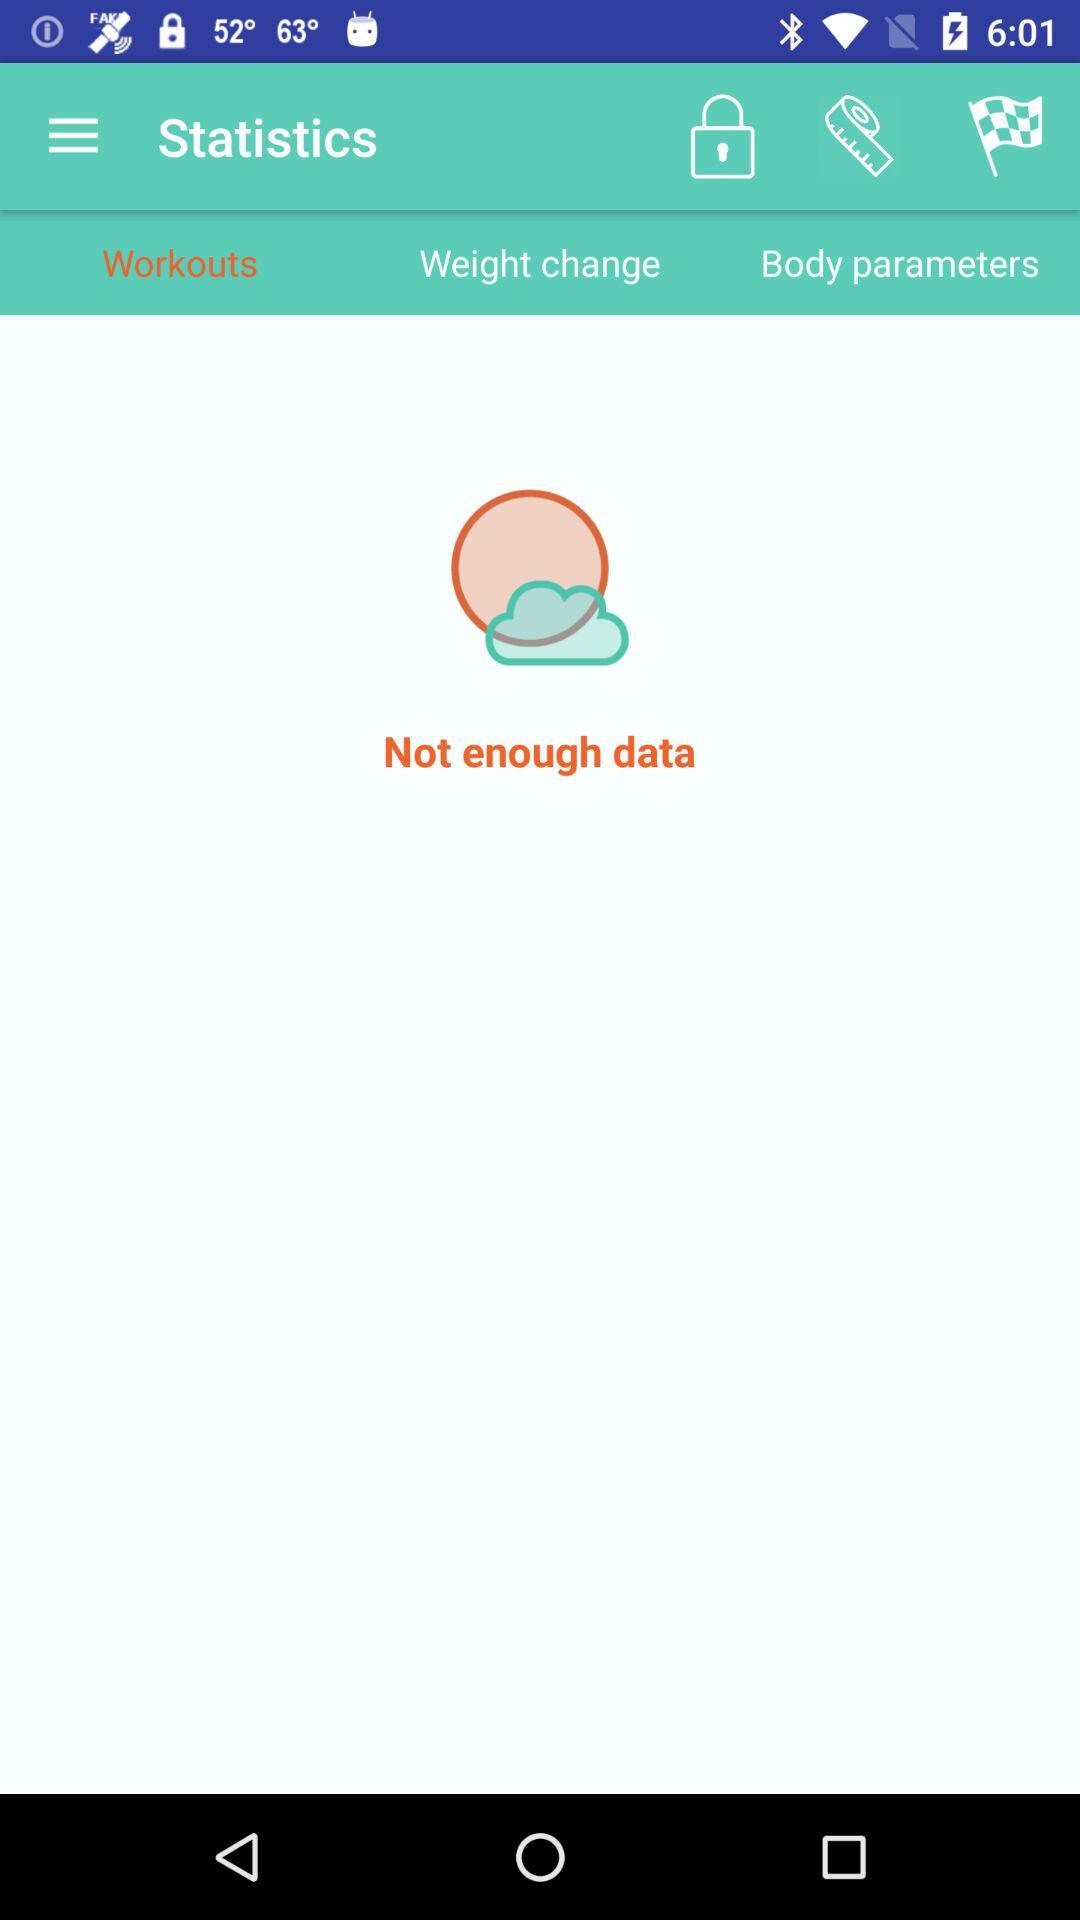Which tab is selected? The selected tab is "Workouts". 